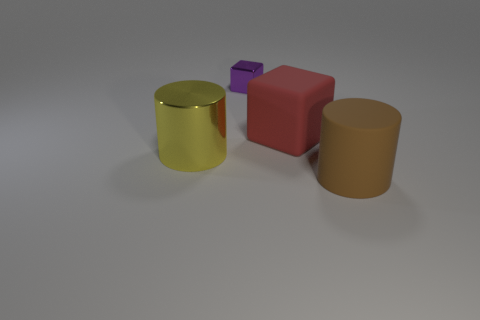Add 1 green metallic cubes. How many objects exist? 5 Subtract 0 green cylinders. How many objects are left? 4 Subtract all large rubber cylinders. Subtract all red rubber cubes. How many objects are left? 2 Add 3 big brown cylinders. How many big brown cylinders are left? 4 Add 4 big red things. How many big red things exist? 5 